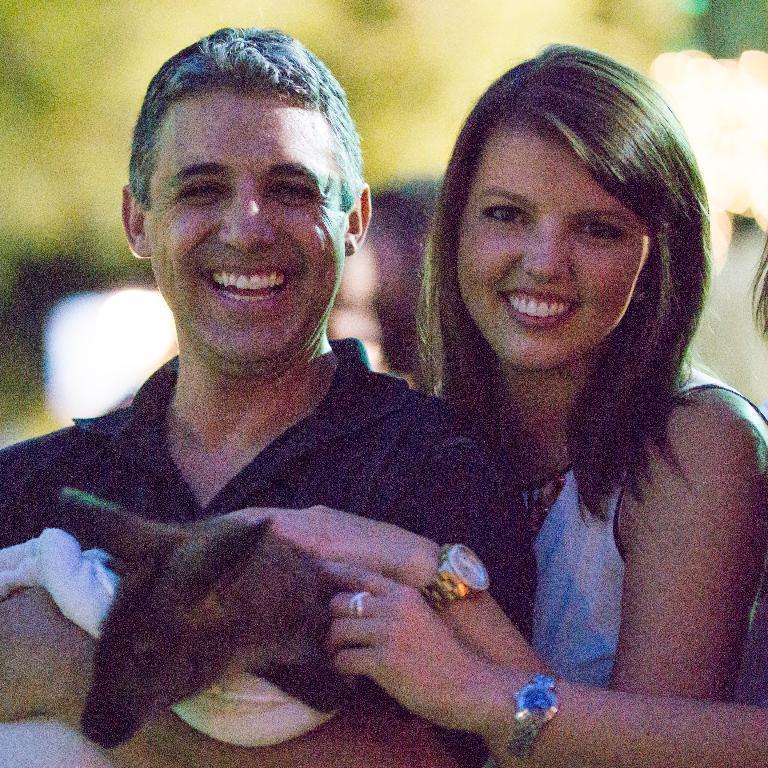Could you give a brief overview of what you see in this image? On the left side of the image there is a man smiling and holding an animal in the hand. Beside him there is a lady smiling and on her hand there is a watch. And also there is another hand with watch. And there is a blur background. 